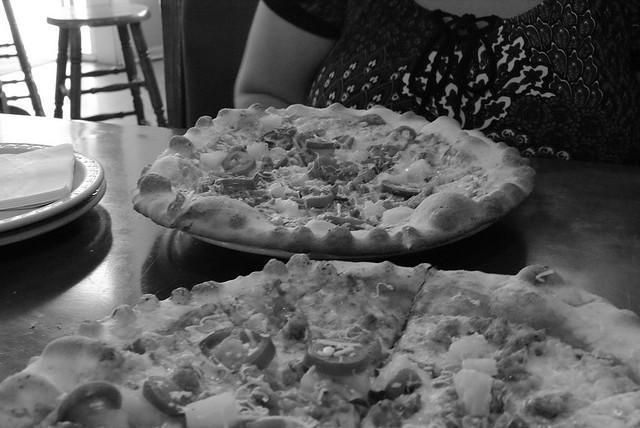Where was this food placed during cooking?
Choose the correct response and explain in the format: 'Answer: answer
Rationale: rationale.'
Options: Counter top, deep fryer, microwave, oven. Answer: oven.
Rationale: Pies are on a table. 